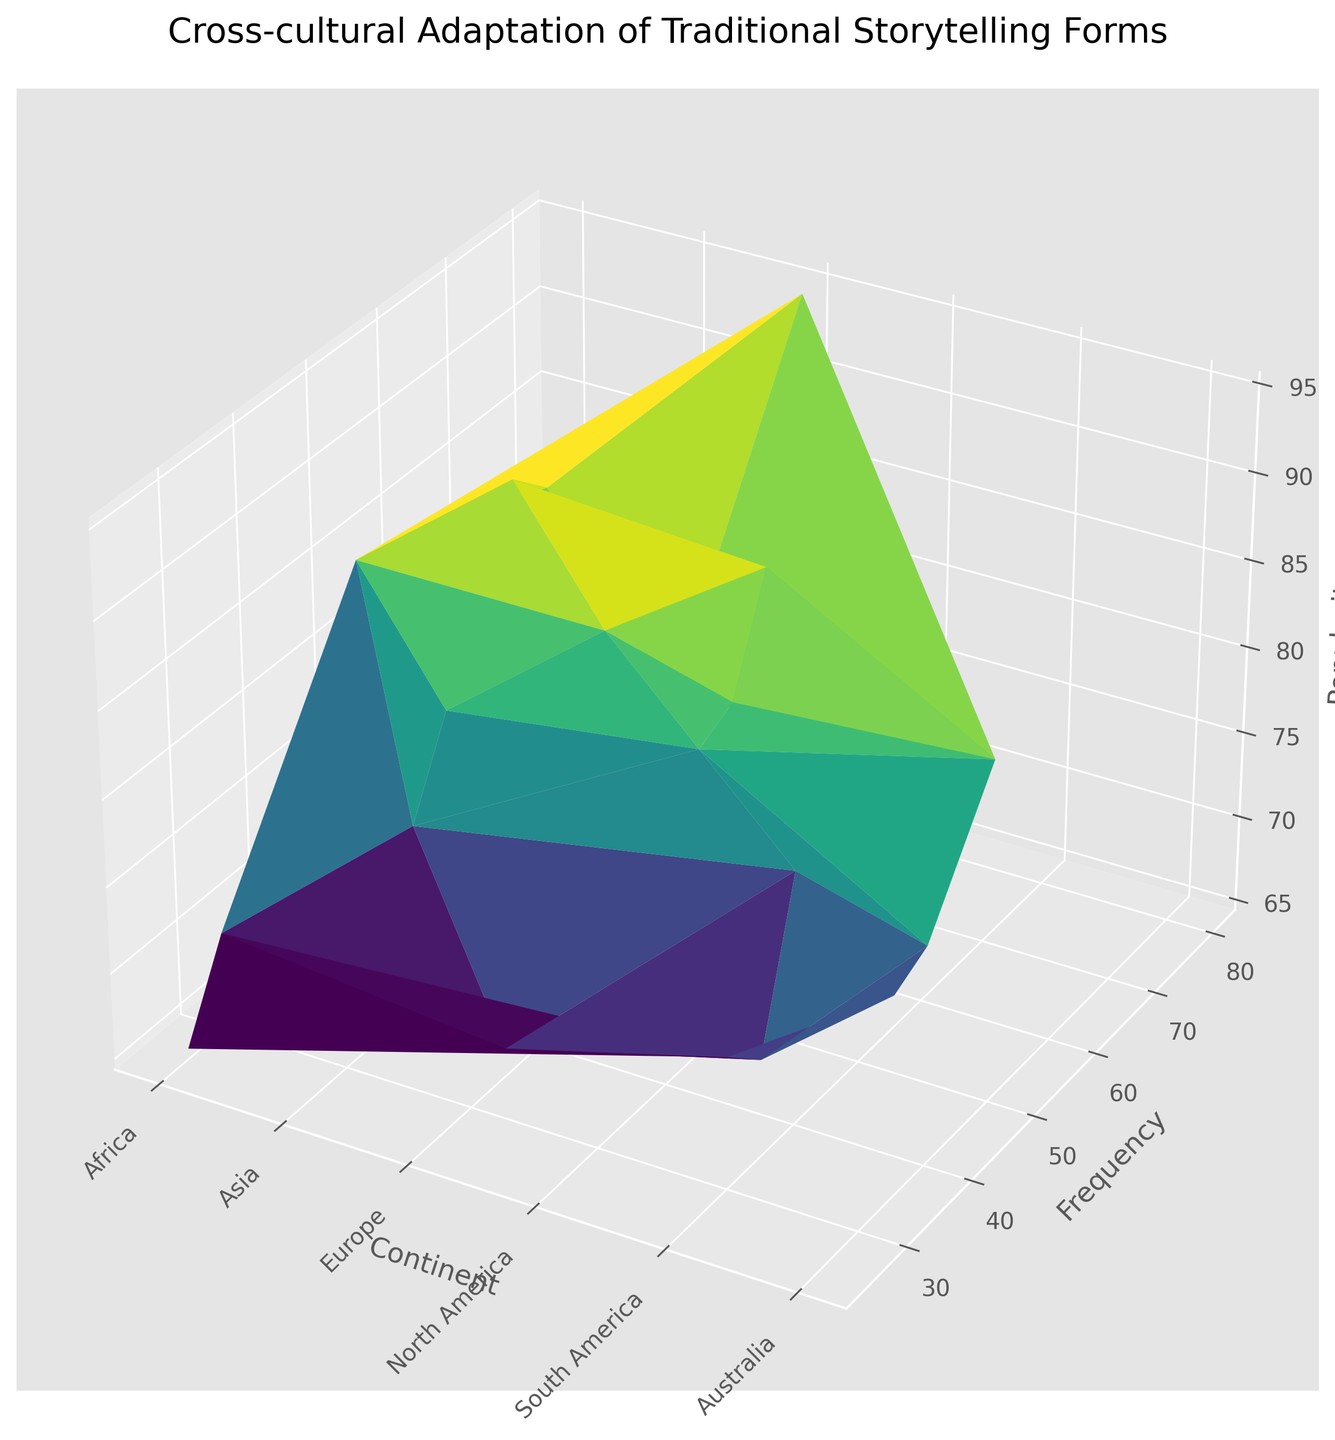Which continent has the highest frequency of traditional storytelling forms with a popularity greater than 80? To answer this, we first identify the traditional forms with a popularity greater than 80. Then, within this group, we sum the frequencies for each continent and determine which continent has the highest total frequency. The continents and their respective total frequencies for forms with popularity greater than 80 are: Africa (50), Asia (115), Europe (190), North America (100), and Australia (50). Therefore, Europe has the highest frequency.
Answer: Europe Which traditional storytelling form has the highest popularity in Asia? To find this, we examine the "popularity" values for each traditional form in Asia and identify the highest value. The popularities are Noh Theatre (80), Peking Opera (90), Kathakali Dance (88), and Shadow Puppetry (75). The highest popularity is for Peking Opera.
Answer: Peking Opera What is the average popularity of traditional storytelling forms in Africa? First, list the popularity values for Africa: Griot Performance (85), Puppetry (70), Story Circles (65). Then, calculate the average: (85 + 70 + 65) / 3 = 220 / 3 ≈ 73.3.
Answer: 73.3 Compare the frequency of traditional storytelling forms in Asia and North America. Which continent has a higher total frequency? Summarize the frequency for each continent. For Asia: Noh Theatre (45), Peking Opera (55), Kathakali Dance (60), Shadow Puppetry (40) sum to 200. For North America: Native American Storytelling (45), Vaudeville (55), Story Slams (50) sum to 150. Asia has the higher total frequency.
Answer: Asia Identify the continent with the lowest average popularity of its traditional storytelling forms. What is the average popularity for that continent? Calculate the average popularity for each continent: Africa (73.3), Asia (83.25), Europe (81), North America (84.67), South America (73.67), Australia (79). Africa, with an average of 73.3, has the lowest average popularity.
Answer: Africa Determine which continent has the most diverse range of traditional storytelling forms by counting how many different forms each continent has. Count the unique storytelling forms listed per continent: Africa (3), Asia (4), Europe (4), North America (3), South America (3), Australia (3). Asia and Europe both have the highest diversity with 4 forms each.
Answer: Asia and Europe For continents with at least three traditional forms represented, identify the one with the highest average frequency. What is the average frequency for that continent? Calculate the average frequency for continents with at least three forms: Africa (35), Asia (50), Europe (56.25), North America (50), South America (35), Australia (41.67). Europe has the highest average frequency of 56.25.
Answer: Europe 